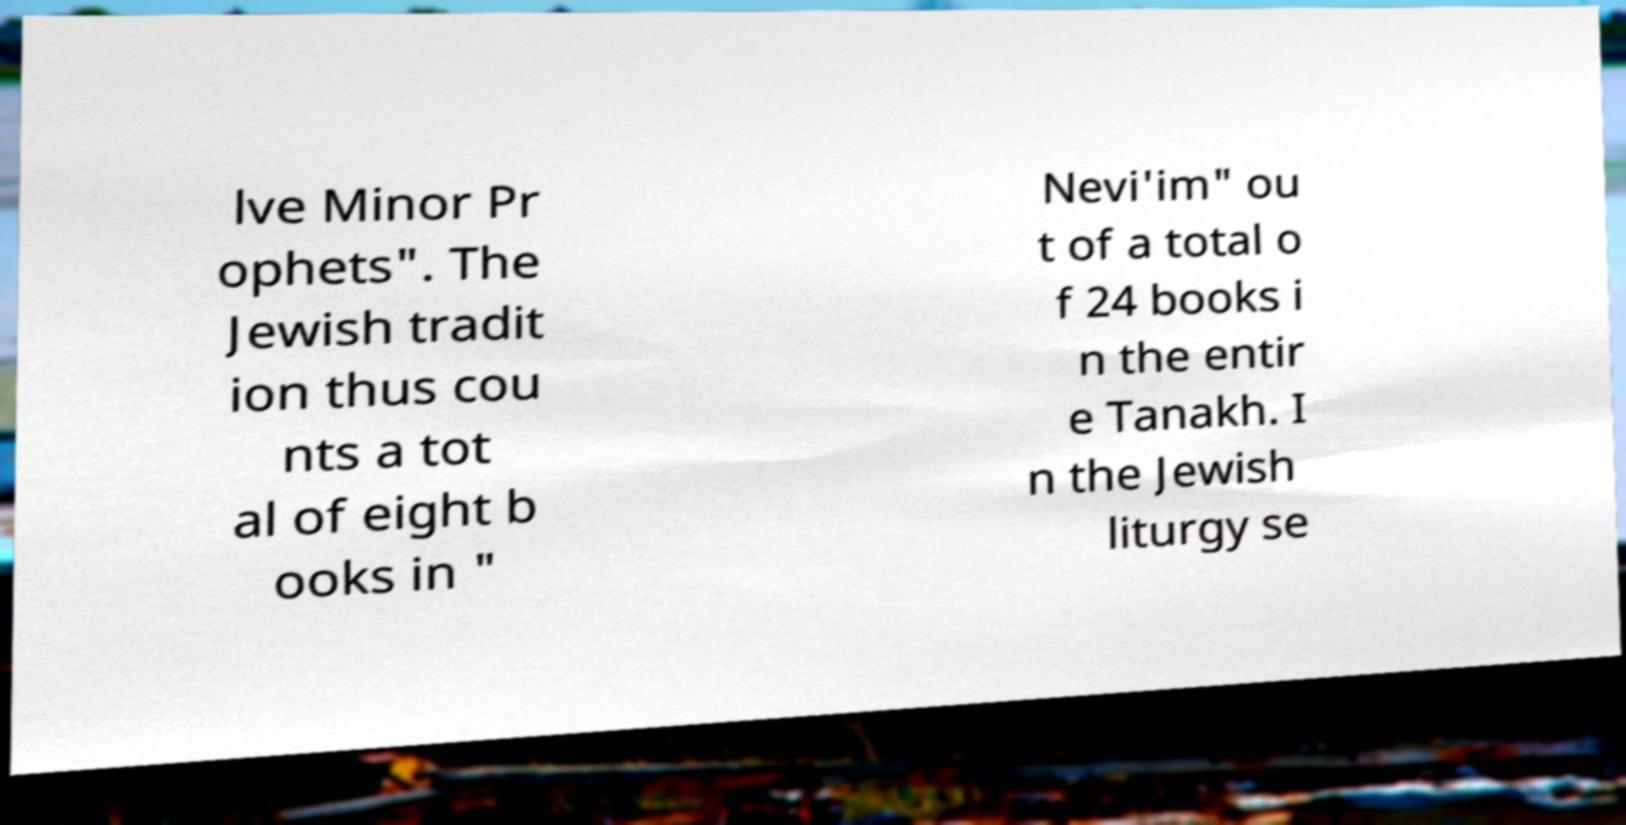There's text embedded in this image that I need extracted. Can you transcribe it verbatim? lve Minor Pr ophets". The Jewish tradit ion thus cou nts a tot al of eight b ooks in " Nevi'im" ou t of a total o f 24 books i n the entir e Tanakh. I n the Jewish liturgy se 